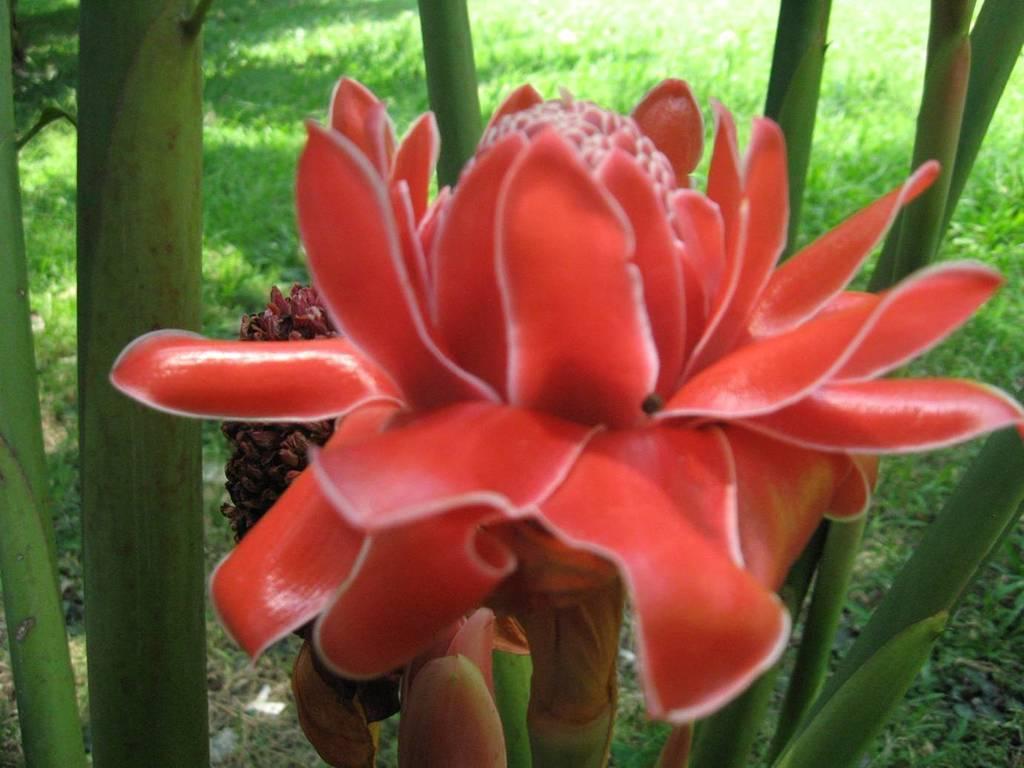Describe this image in one or two sentences. This image consists of a flower. It is in red color. There is grass in this image. 